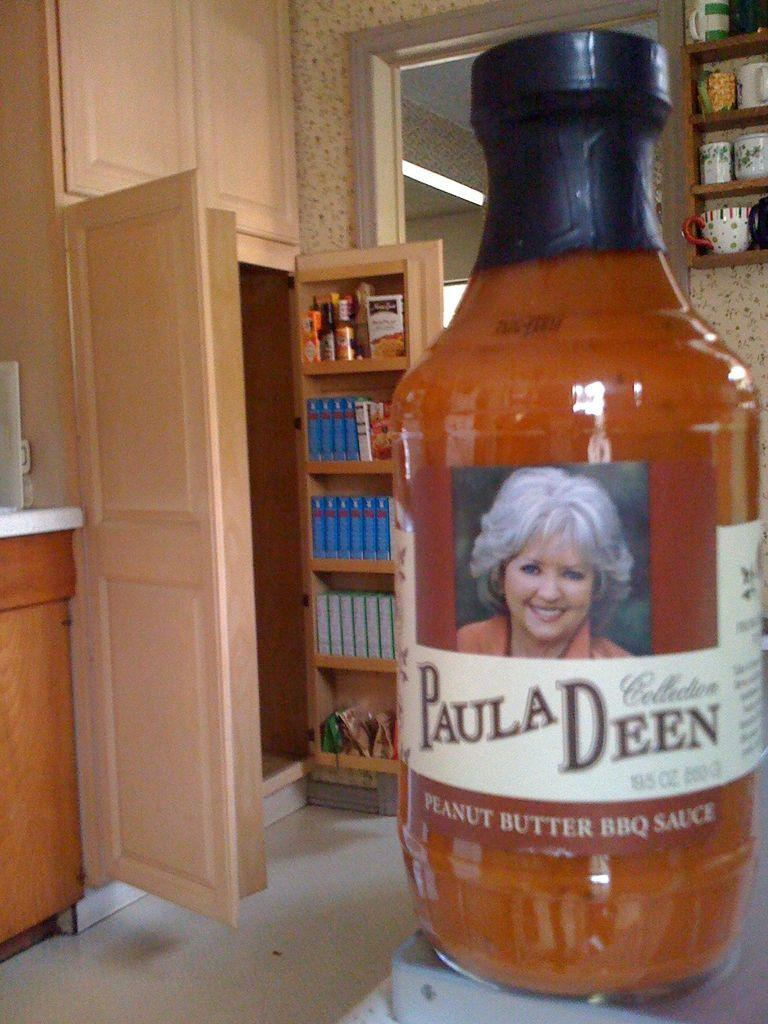<image>
Relay a brief, clear account of the picture shown. Paula Deen's peanut butter BBQ sauce in a jar. 